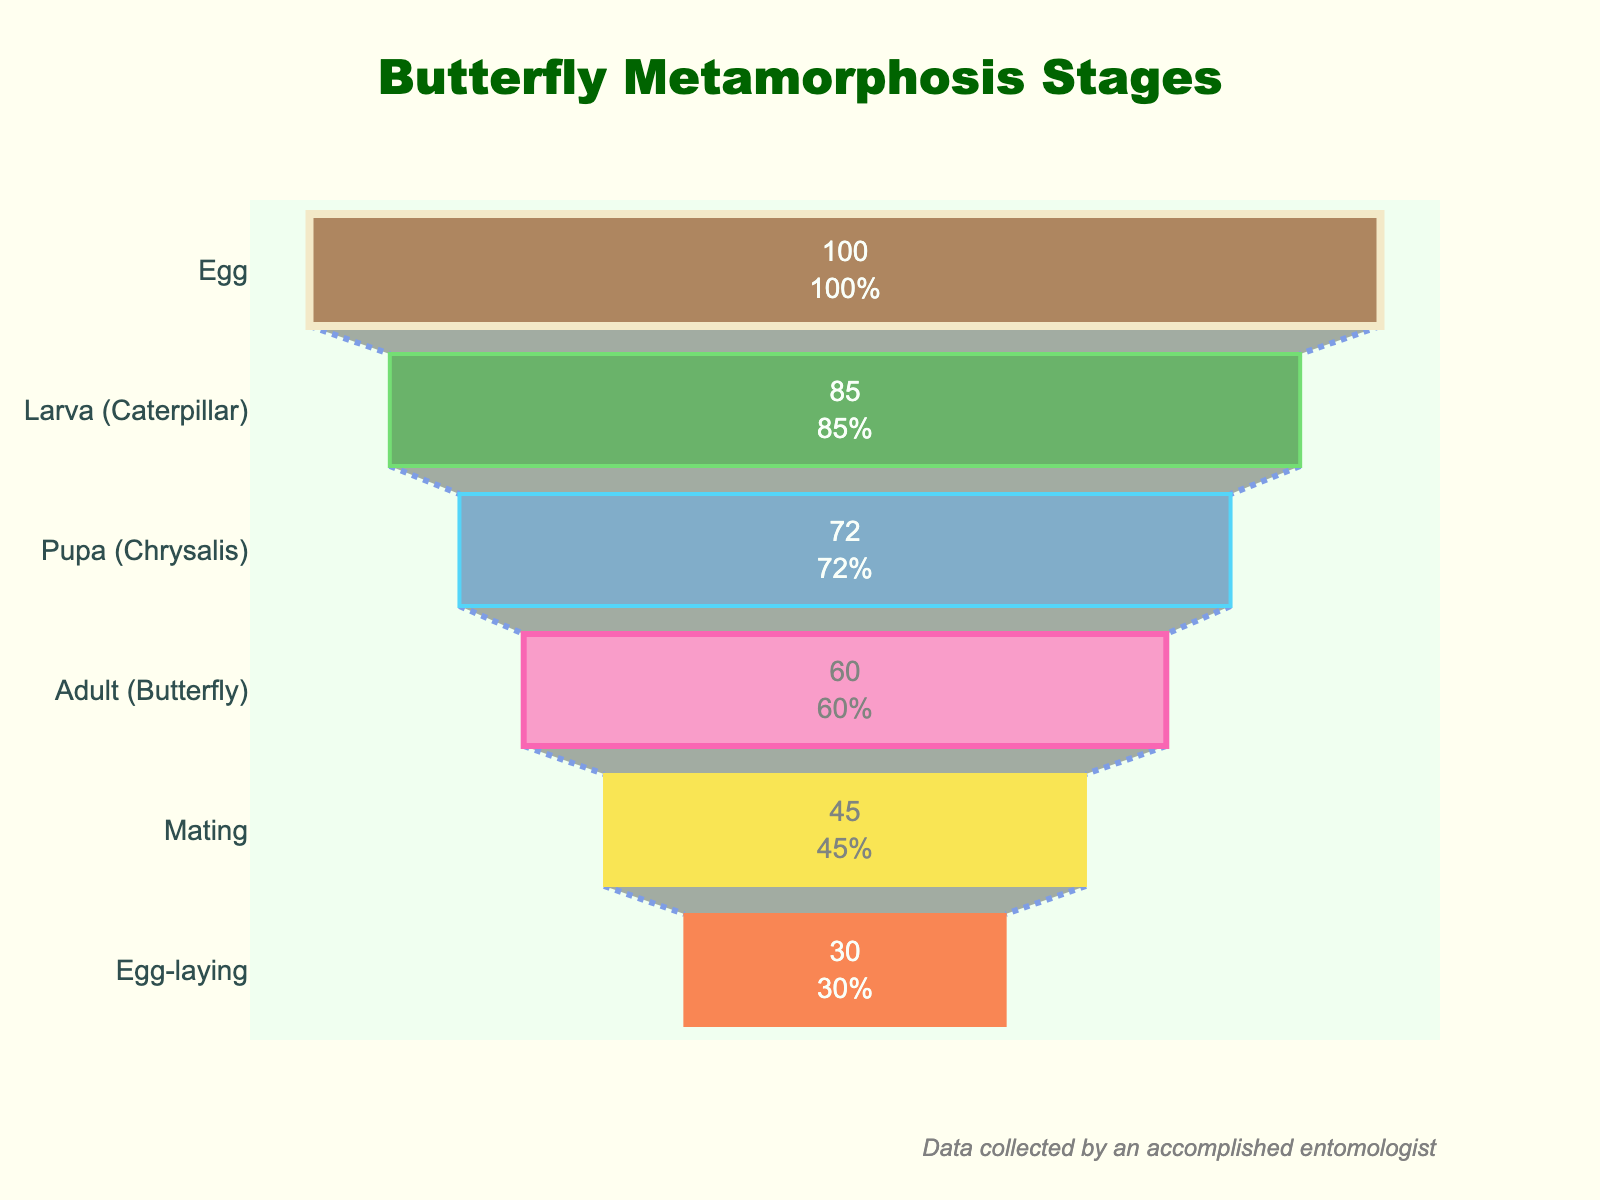What is the title of the figure? The title is usually found at the top of the figure. In this figure, the title is centered at the top and reads "Butterfly Metamorphosis Stages."
Answer: Butterfly Metamorphosis Stages What stage has the highest percentage of individuals? The highest percentage is represented by the tallest section of the funnel, which is the "Egg" stage at 100%.
Answer: Egg What is the percentage difference between the Larva (Caterpillar) stage and the Adult (Butterfly) stage? To find the difference, subtract the percentage of the Adult (Butterfly) stage from the Larva (Caterpillar) stage: 85% - 60% = 25%.
Answer: 25% Which stage represents the smallest percentage of individuals? The smallest percentage is depicted by the smallest section of the funnel, which corresponds to the "Egg-laying" stage at 30%.
Answer: Egg-laying How many stages are shown in the Funnel Chart? By counting the distinct sections of the funnel, we can determine that there are six stages represented in the chart.
Answer: Six What is the percentage of individuals in the Pupa (Chrysalis) stage? The figure lists the percentage values inside each section. The Pupa (Chrysalis) stage shows a value of 72%.
Answer: 72% Is the percentage of individuals in the Mating stage greater than that in the Egg-laying stage? Compare the percentages directly: 45% for Mating and 30% for Egg-laying. 45% is greater than 30%.
Answer: Yes What is the combined percentage of individuals in the stages from Larva (Caterpillar) to Adult (Butterfly)? Add the percentages of the Larva (Caterpillar) stage (85%), the Pupa (Chrysalis) stage (72%), and the Adult (Butterfly) stage (60%). 85% + 72% + 60% = 217%.
Answer: 217% Which stage shows the steepest drop in percentages when transitioning from the previous stage? Calculate the differences between consecutive stages: Egg to Larva (100%-85%=15%), Larva to Pupa (85% - 72% = 13%), Pupa to Adult (72% - 60% = 12%), Adult to Mating (60% - 45% = 15%), and Mating to Egg-laying (45% - 30% = 15%). The largest single drop doesn't show a unique stage but a tie among "Egg to Larva", "Adult to Mating", and "Mating to Egg-laying".
Answer: Egg to Larva, Adult to Mating, and Mating to Egg-laying How does the color of the Pupa (Chrysalis) stage differ from the Mating stage in the figure? The Pupa (Chrysalis) stage is colored blue, while the Mating stage is colored golden. Color differences help distinguish different stages visually.
Answer: Blue and Golden 